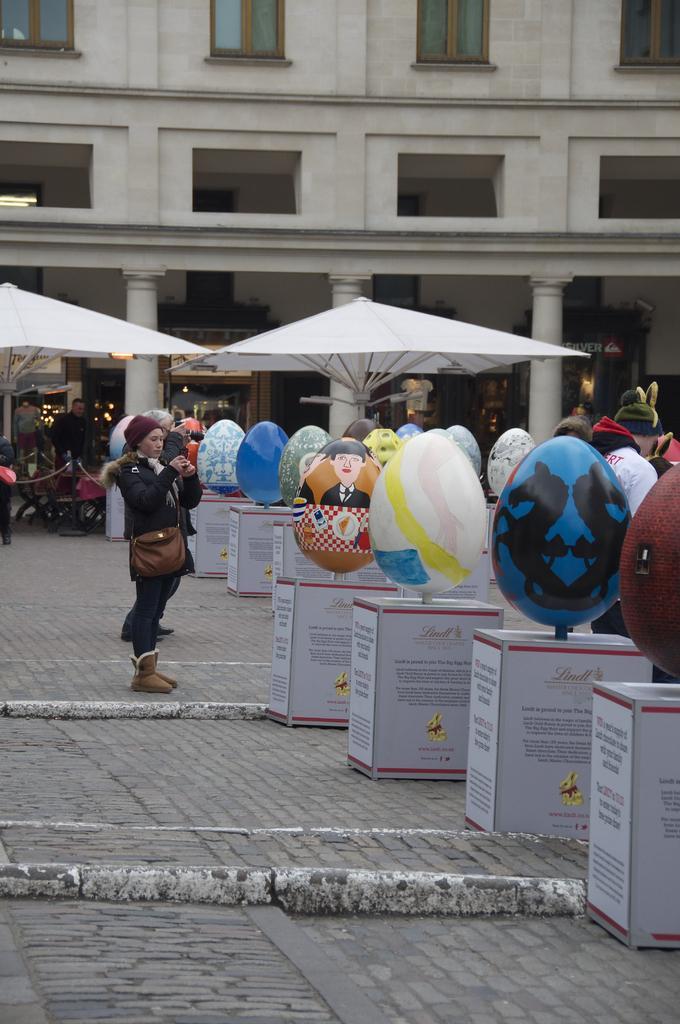In one or two sentences, can you explain what this image depicts? In this image I can see balloons stands, crowd and umbrella huts. In the background I can see a building and windows. This image is taken during a day. 